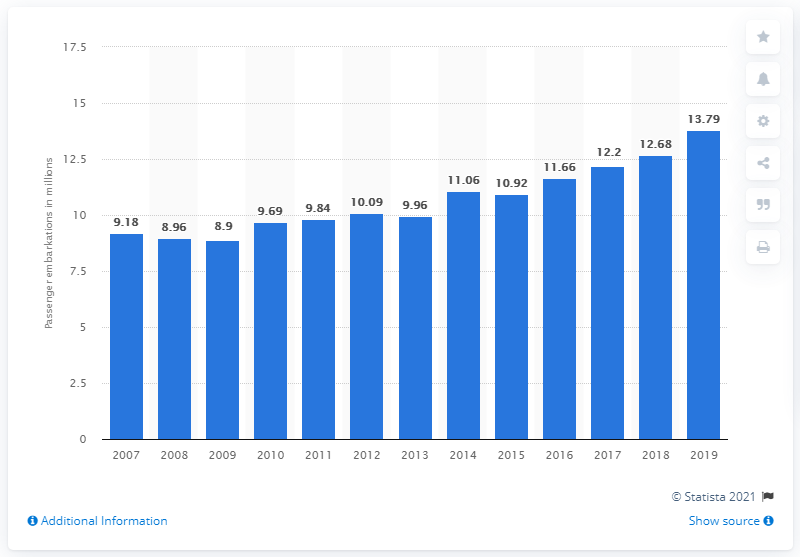Outline some significant characteristics in this image. The number of cruise passenger embarkations in the United States increased steadily between 2015 and the present. In 2019, a total of 13,790 cruise passenger embarkations occurred at U.S. ports. 